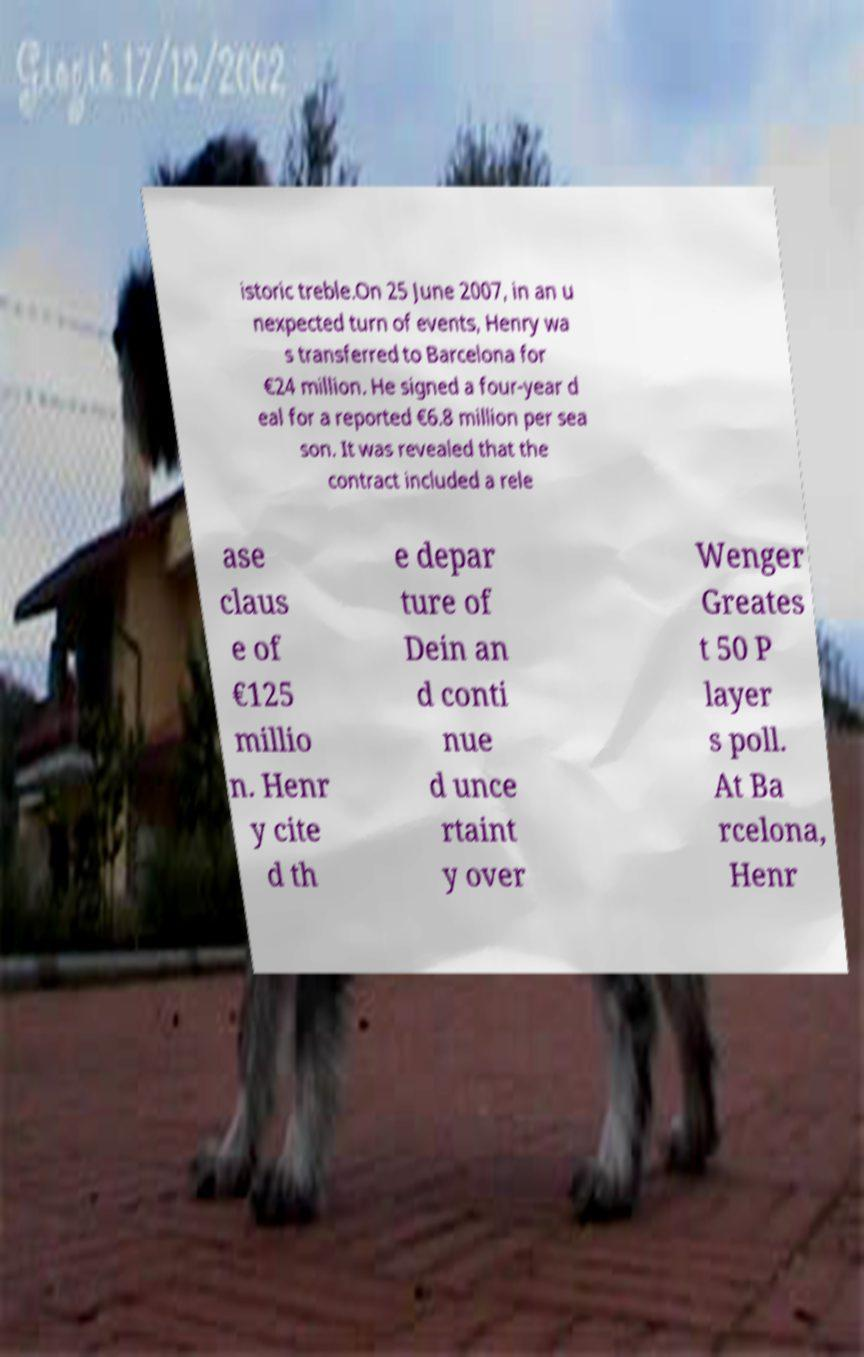There's text embedded in this image that I need extracted. Can you transcribe it verbatim? istoric treble.On 25 June 2007, in an u nexpected turn of events, Henry wa s transferred to Barcelona for €24 million. He signed a four-year d eal for a reported €6.8 million per sea son. It was revealed that the contract included a rele ase claus e of €125 millio n. Henr y cite d th e depar ture of Dein an d conti nue d unce rtaint y over Wenger Greates t 50 P layer s poll. At Ba rcelona, Henr 